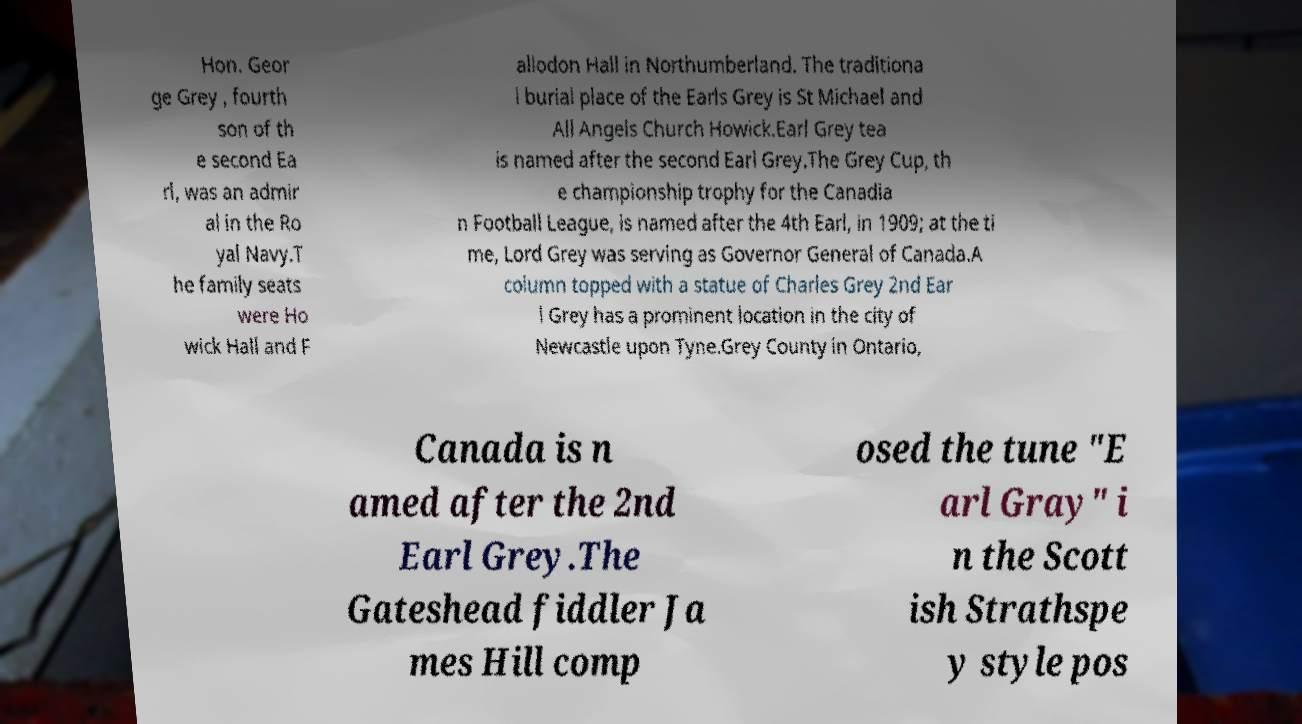Could you extract and type out the text from this image? Hon. Geor ge Grey , fourth son of th e second Ea rl, was an admir al in the Ro yal Navy.T he family seats were Ho wick Hall and F allodon Hall in Northumberland. The traditiona l burial place of the Earls Grey is St Michael and All Angels Church Howick.Earl Grey tea is named after the second Earl Grey.The Grey Cup, th e championship trophy for the Canadia n Football League, is named after the 4th Earl, in 1909; at the ti me, Lord Grey was serving as Governor General of Canada.A column topped with a statue of Charles Grey 2nd Ear l Grey has a prominent location in the city of Newcastle upon Tyne.Grey County in Ontario, Canada is n amed after the 2nd Earl Grey.The Gateshead fiddler Ja mes Hill comp osed the tune "E arl Gray" i n the Scott ish Strathspe y style pos 